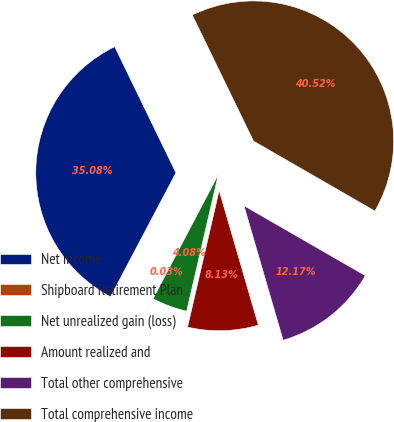Convert chart to OTSL. <chart><loc_0><loc_0><loc_500><loc_500><pie_chart><fcel>Net income<fcel>Shipboard Retirement Plan<fcel>Net unrealized gain (loss)<fcel>Amount realized and<fcel>Total other comprehensive<fcel>Total comprehensive income<nl><fcel>35.08%<fcel>0.03%<fcel>4.08%<fcel>8.13%<fcel>12.17%<fcel>40.52%<nl></chart> 